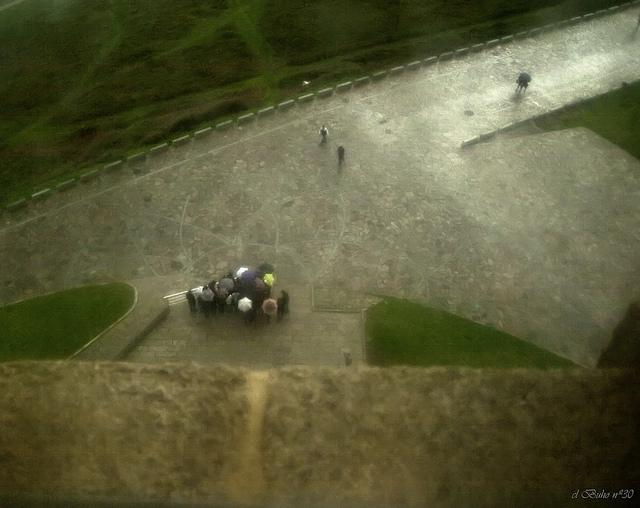What are the objects held in the small group of people at the mouth of this road? umbrella 